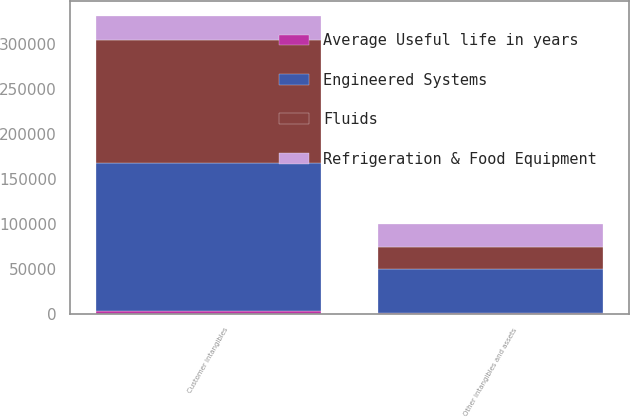Convert chart. <chart><loc_0><loc_0><loc_500><loc_500><stacked_bar_chart><ecel><fcel>Customer intangibles<fcel>Other intangibles and assets<nl><fcel>Fluids<fcel>136495<fcel>24405<nl><fcel>Refrigeration & Food Equipment<fcel>26866<fcel>25000<nl><fcel>Average Useful life in years<fcel>2500<fcel>300<nl><fcel>Engineered Systems<fcel>165861<fcel>49705<nl></chart> 